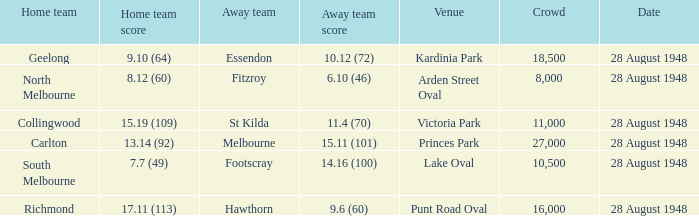Give me the full table as a dictionary. {'header': ['Home team', 'Home team score', 'Away team', 'Away team score', 'Venue', 'Crowd', 'Date'], 'rows': [['Geelong', '9.10 (64)', 'Essendon', '10.12 (72)', 'Kardinia Park', '18,500', '28 August 1948'], ['North Melbourne', '8.12 (60)', 'Fitzroy', '6.10 (46)', 'Arden Street Oval', '8,000', '28 August 1948'], ['Collingwood', '15.19 (109)', 'St Kilda', '11.4 (70)', 'Victoria Park', '11,000', '28 August 1948'], ['Carlton', '13.14 (92)', 'Melbourne', '15.11 (101)', 'Princes Park', '27,000', '28 August 1948'], ['South Melbourne', '7.7 (49)', 'Footscray', '14.16 (100)', 'Lake Oval', '10,500', '28 August 1948'], ['Richmond', '17.11 (113)', 'Hawthorn', '9.6 (60)', 'Punt Road Oval', '16,000', '28 August 1948']]} What is the St Kilda Away team score? 11.4 (70). 